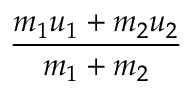<formula> <loc_0><loc_0><loc_500><loc_500>\frac { m _ { 1 } u _ { 1 } + m _ { 2 } u _ { 2 } } { m _ { 1 } + m _ { 2 } }</formula> 